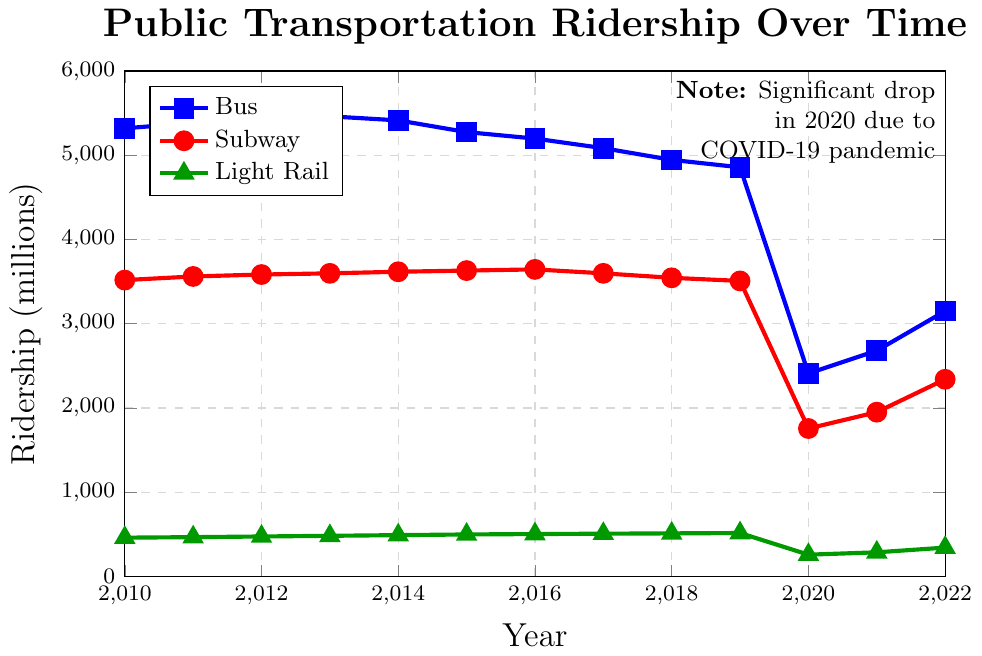What is the trend in bus ridership from 2010 to 2022? From the visual graph, the bus ridership starts at 5320 million in 2010 and gradually decreases with a slight fluctuation till 2019. A significant drop occurs in 2020, likely due to the COVID-19 pandemic, followed by a slight recovery trend in 2021 and 2022.
Answer: Gradual decrease with a significant drop in 2020, then slight recovery Which year had the highest subway ridership? The highest subway ridership can be identified by the red line on the chart, peaking in the year with the largest value. The peak value occurs in 2016 at 3645 million.
Answer: 2016 How did light rail ridership change during the pandemic years (2020-2022)? The green line representing light rail ridership shows a major decline from 515 million in 2019 to 258 million in 2020, then increases to 286 million in 2021 and further to 342 million in 2022. This indicates an initial sharp drop, followed by a gradual recovery.
Answer: Sharp drop in 2020, gradual recovery in 2021 and 2022 Compare the bus ridership in 2010 and 2022. Which year had higher ridership and by how much? The bus ridership in 2010 is 5320 million, whereas in 2022, it is 3150 million. To find the difference, subtract the latter from the former: 5320 - 3150 = 2170 million.
Answer: 2010, by 2170 million What was the combined ridership of all transportation modes in 2020? Sum the ridership values of bus, subway, and light rail in 2020: 2410 (bus) + 1756 (subway) + 258 (light rail) = 4424 million.
Answer: 4424 million Which transportation mode had the least impact from the pandemic in 2020 compared to 2019? Calculate the percentage drop for each mode from 2019 to 2020:
- Bus: ((4857 - 2410) / 4857) * 100 ≈ 50.4%
- Subway: ((3508 - 1756) / 3508) * 100 ≈ 49.9%
- Light Rail: ((515 - 258) / 515) * 100 ≈ 49.9%
Both the subway and light rail had approximately the same percentage drops.
Answer: Subway and Light Rail, both approximately 49.9% What was the percent increase in bus ridership from its lowest point in 2020 to 2022? Calculate the increase and then the percentage based on the 2020 value:
Increase = 3150 (2022) - 2410 (2020) = 740 million.
Percentage increase = (740 / 2410) * 100 ≈ 30.7%.
Answer: 30.7% Between 2015 and 2016, which transportation mode saw a ridership increase and which saw a decrease? By comparing the values from 2015 to 2016 for each mode:
- Bus ridership decreased from 5275 to 5198.
- Subway ridership increased from 3631 to 3645.
- Light rail ridership increased from 498 to 503.
Thus, the bus saw a decrease, while subway and light rail saw increases.
Answer: Bus: decrease, Subway: increase, Light Rail: increase In which year did the bus ridership fall below 4000 million for the first time? Observing the blue line, the bus ridership drops below 4000 million in the year 2020.
Answer: 2020 